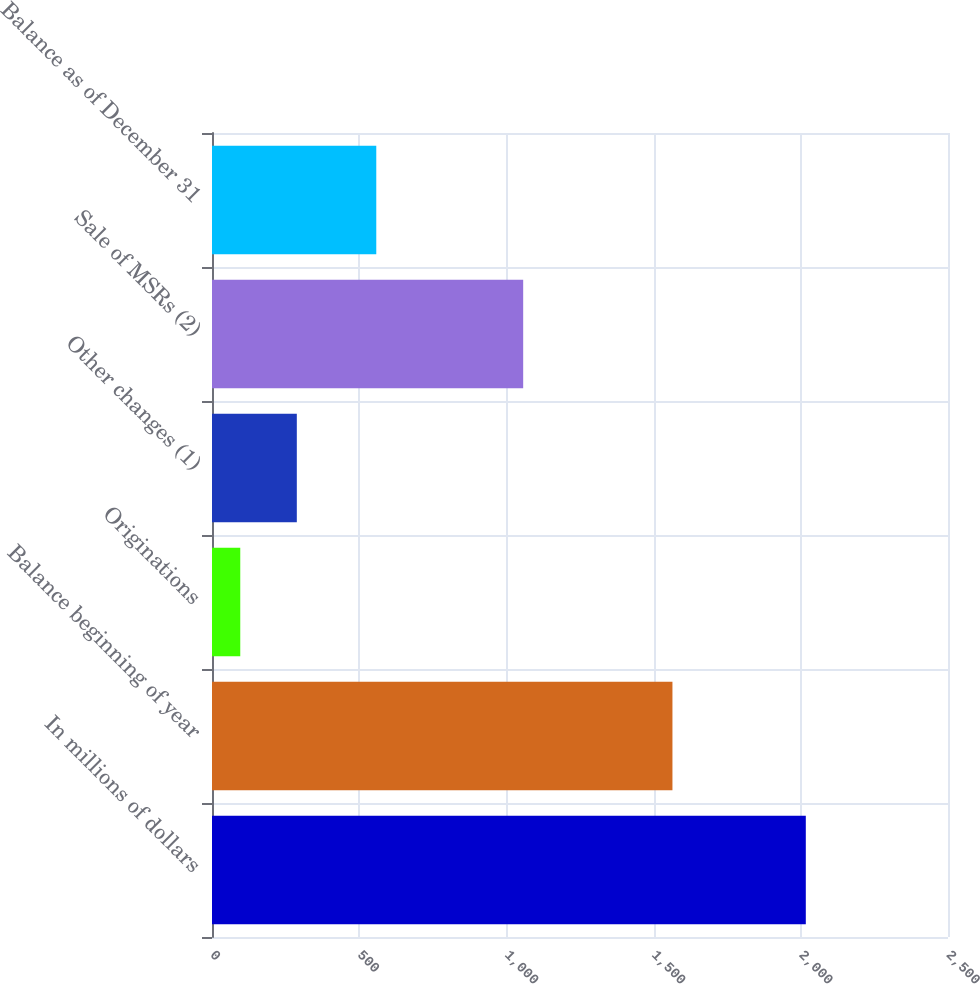Convert chart to OTSL. <chart><loc_0><loc_0><loc_500><loc_500><bar_chart><fcel>In millions of dollars<fcel>Balance beginning of year<fcel>Originations<fcel>Other changes (1)<fcel>Sale of MSRs (2)<fcel>Balance as of December 31<nl><fcel>2017<fcel>1564<fcel>96<fcel>288.1<fcel>1057<fcel>558<nl></chart> 